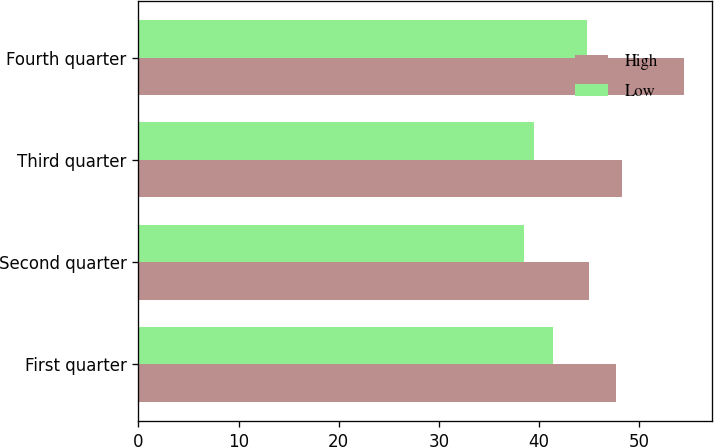<chart> <loc_0><loc_0><loc_500><loc_500><stacked_bar_chart><ecel><fcel>First quarter<fcel>Second quarter<fcel>Third quarter<fcel>Fourth quarter<nl><fcel>High<fcel>47.71<fcel>45<fcel>48.26<fcel>54.5<nl><fcel>Low<fcel>41.42<fcel>38.53<fcel>39.44<fcel>44.75<nl></chart> 